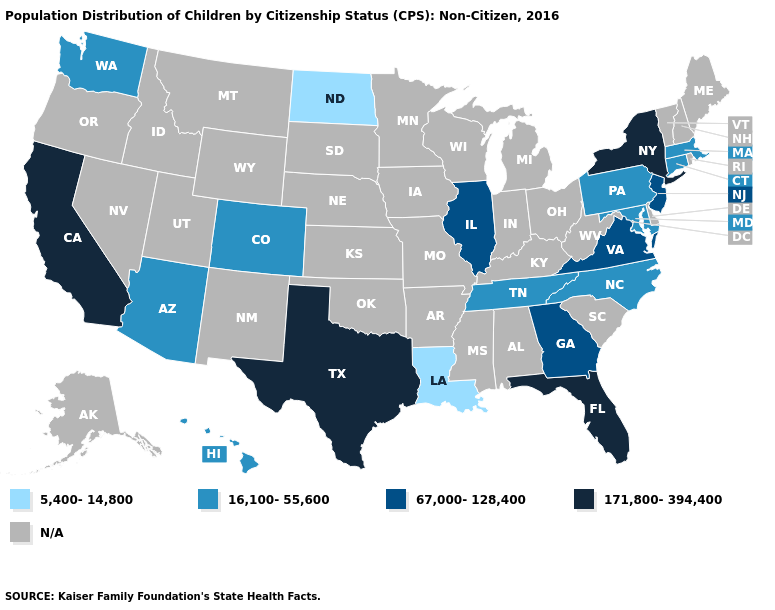Which states have the highest value in the USA?
Give a very brief answer. California, Florida, New York, Texas. Is the legend a continuous bar?
Short answer required. No. What is the lowest value in the USA?
Give a very brief answer. 5,400-14,800. Which states have the highest value in the USA?
Answer briefly. California, Florida, New York, Texas. What is the highest value in states that border West Virginia?
Answer briefly. 67,000-128,400. Is the legend a continuous bar?
Keep it brief. No. Does the first symbol in the legend represent the smallest category?
Short answer required. Yes. What is the lowest value in the USA?
Give a very brief answer. 5,400-14,800. What is the value of Oklahoma?
Answer briefly. N/A. What is the highest value in the South ?
Short answer required. 171,800-394,400. Does Georgia have the highest value in the South?
Write a very short answer. No. What is the highest value in the USA?
Concise answer only. 171,800-394,400. Name the states that have a value in the range 171,800-394,400?
Be succinct. California, Florida, New York, Texas. Which states have the lowest value in the USA?
Concise answer only. Louisiana, North Dakota. What is the value of Utah?
Write a very short answer. N/A. 